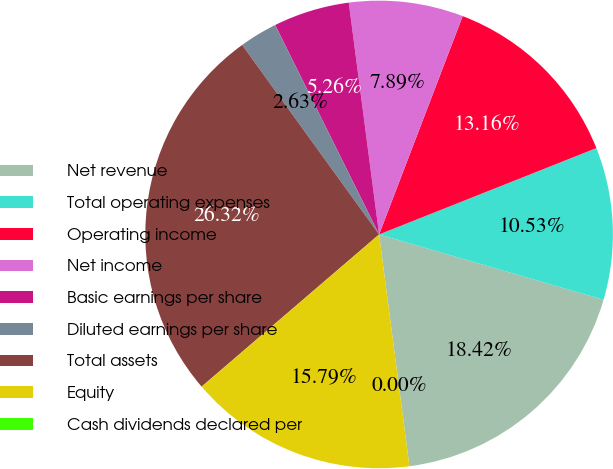Convert chart. <chart><loc_0><loc_0><loc_500><loc_500><pie_chart><fcel>Net revenue<fcel>Total operating expenses<fcel>Operating income<fcel>Net income<fcel>Basic earnings per share<fcel>Diluted earnings per share<fcel>Total assets<fcel>Equity<fcel>Cash dividends declared per<nl><fcel>18.42%<fcel>10.53%<fcel>13.16%<fcel>7.89%<fcel>5.26%<fcel>2.63%<fcel>26.32%<fcel>15.79%<fcel>0.0%<nl></chart> 